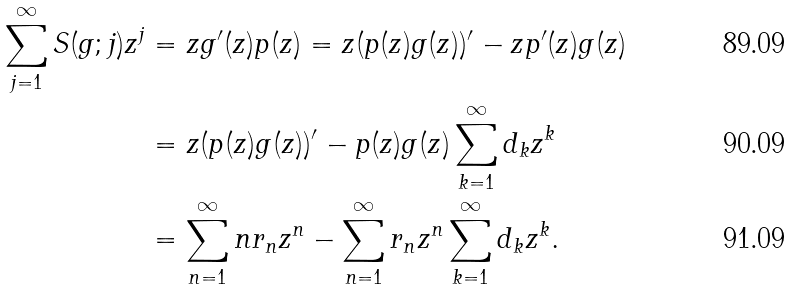Convert formula to latex. <formula><loc_0><loc_0><loc_500><loc_500>\sum _ { j = 1 } ^ { \infty } S ( g ; j ) z ^ { j } & = z g ^ { \prime } ( z ) p ( z ) = z ( p ( z ) g ( z ) ) ^ { \prime } - z p ^ { \prime } ( z ) g ( z ) \\ & = z ( p ( z ) g ( z ) ) ^ { \prime } - p ( z ) g ( z ) \sum _ { k = 1 } ^ { \infty } d _ { k } z ^ { k } \\ & = \sum _ { n = 1 } ^ { \infty } n r _ { n } z ^ { n } - \sum _ { n = 1 } ^ { \infty } r _ { n } z ^ { n } \sum _ { k = 1 } ^ { \infty } d _ { k } z ^ { k } .</formula> 